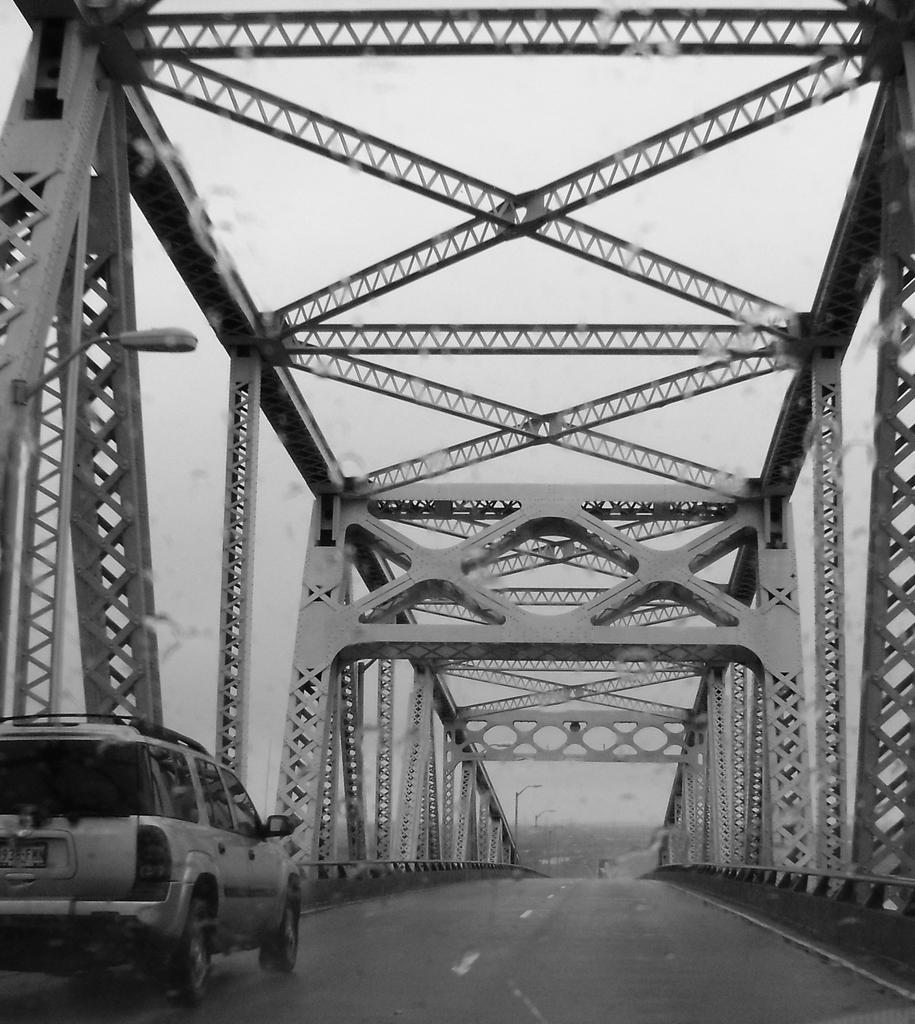In one or two sentences, can you explain what this image depicts? In the foreground of this black and white image, on the left, there is a vehicle moving on a bridge. In the background, we can see few poles and on the top, there is the sky. 